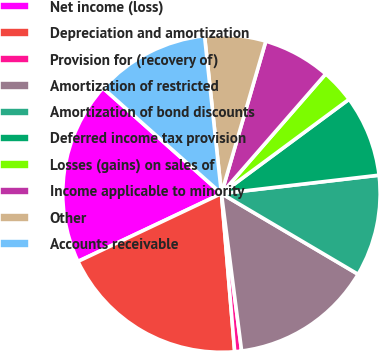<chart> <loc_0><loc_0><loc_500><loc_500><pie_chart><fcel>Net income (loss)<fcel>Depreciation and amortization<fcel>Provision for (recovery of)<fcel>Amortization of restricted<fcel>Amortization of bond discounts<fcel>Deferred income tax provision<fcel>Losses (gains) on sales of<fcel>Income applicable to minority<fcel>Other<fcel>Accounts receivable<nl><fcel>18.61%<fcel>19.3%<fcel>0.7%<fcel>14.48%<fcel>10.34%<fcel>8.28%<fcel>3.46%<fcel>6.9%<fcel>6.21%<fcel>11.72%<nl></chart> 